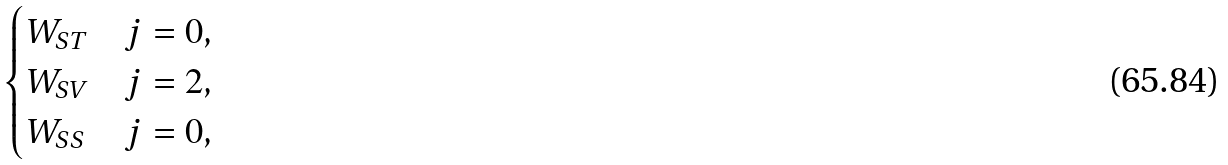Convert formula to latex. <formula><loc_0><loc_0><loc_500><loc_500>\begin{cases} W _ { S T } & \text {$j=0$} , \\ W _ { S V } & \text {$j=2$} , \\ W _ { S S } & \text {$j=0$} , \end{cases}</formula> 